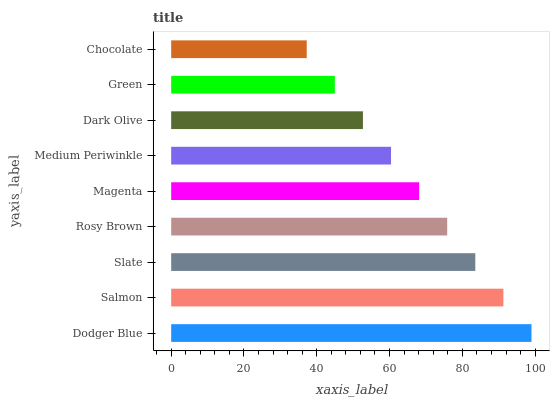Is Chocolate the minimum?
Answer yes or no. Yes. Is Dodger Blue the maximum?
Answer yes or no. Yes. Is Salmon the minimum?
Answer yes or no. No. Is Salmon the maximum?
Answer yes or no. No. Is Dodger Blue greater than Salmon?
Answer yes or no. Yes. Is Salmon less than Dodger Blue?
Answer yes or no. Yes. Is Salmon greater than Dodger Blue?
Answer yes or no. No. Is Dodger Blue less than Salmon?
Answer yes or no. No. Is Magenta the high median?
Answer yes or no. Yes. Is Magenta the low median?
Answer yes or no. Yes. Is Salmon the high median?
Answer yes or no. No. Is Slate the low median?
Answer yes or no. No. 